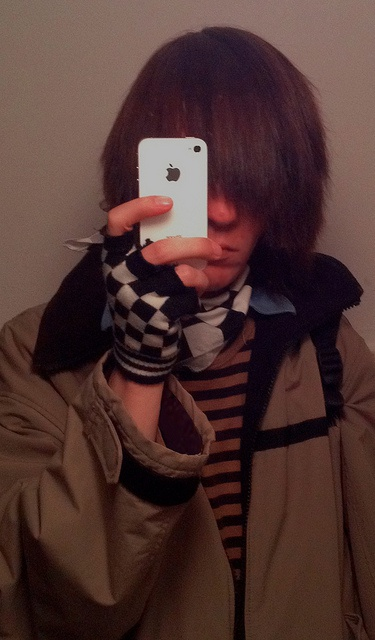Describe the objects in this image and their specific colors. I can see people in black, maroon, gray, and brown tones and cell phone in gray, darkgray, brown, and maroon tones in this image. 